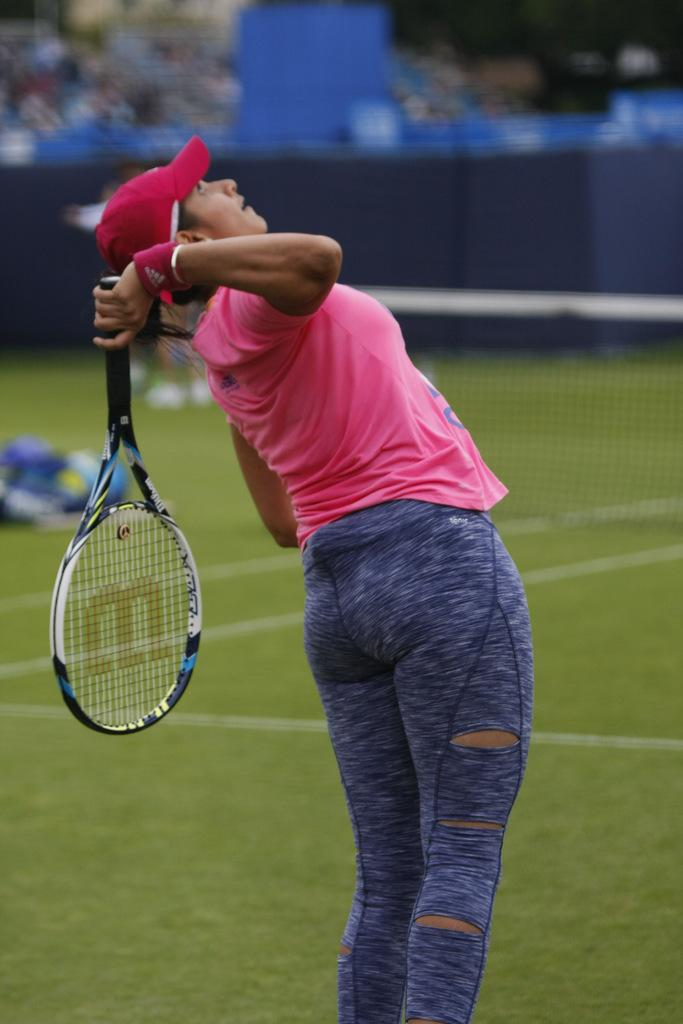Who is the main subject in the image? There is a woman in the image. What is the woman doing in the image? The woman is standing in the image. What object is the woman holding? The woman is holding a racket. What type of headwear is the woman wearing? The woman is wearing a cap. What type of balloon is the woman holding in the image? There is no balloon present in the image; the woman is holding a racket. On what stage is the woman performing in the image? There is no stage present in the image, and the woman is not performing. 